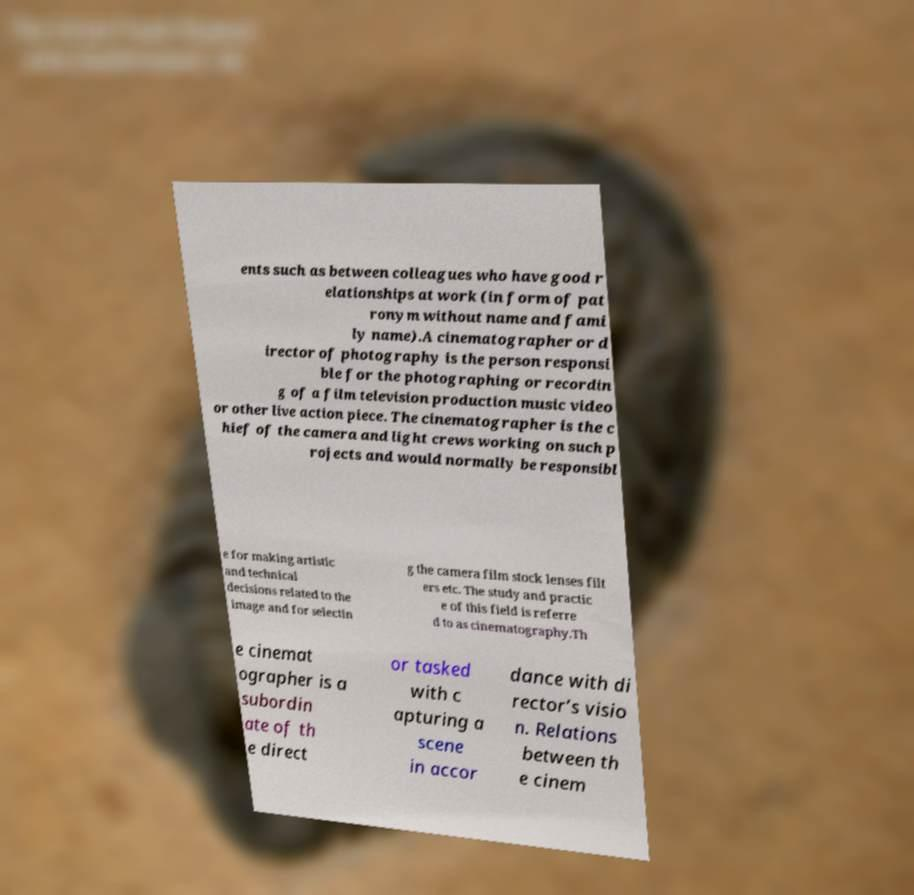Please identify and transcribe the text found in this image. ents such as between colleagues who have good r elationships at work (in form of pat ronym without name and fami ly name).A cinematographer or d irector of photography is the person responsi ble for the photographing or recordin g of a film television production music video or other live action piece. The cinematographer is the c hief of the camera and light crews working on such p rojects and would normally be responsibl e for making artistic and technical decisions related to the image and for selectin g the camera film stock lenses filt ers etc. The study and practic e of this field is referre d to as cinematography.Th e cinemat ographer is a subordin ate of th e direct or tasked with c apturing a scene in accor dance with di rector’s visio n. Relations between th e cinem 